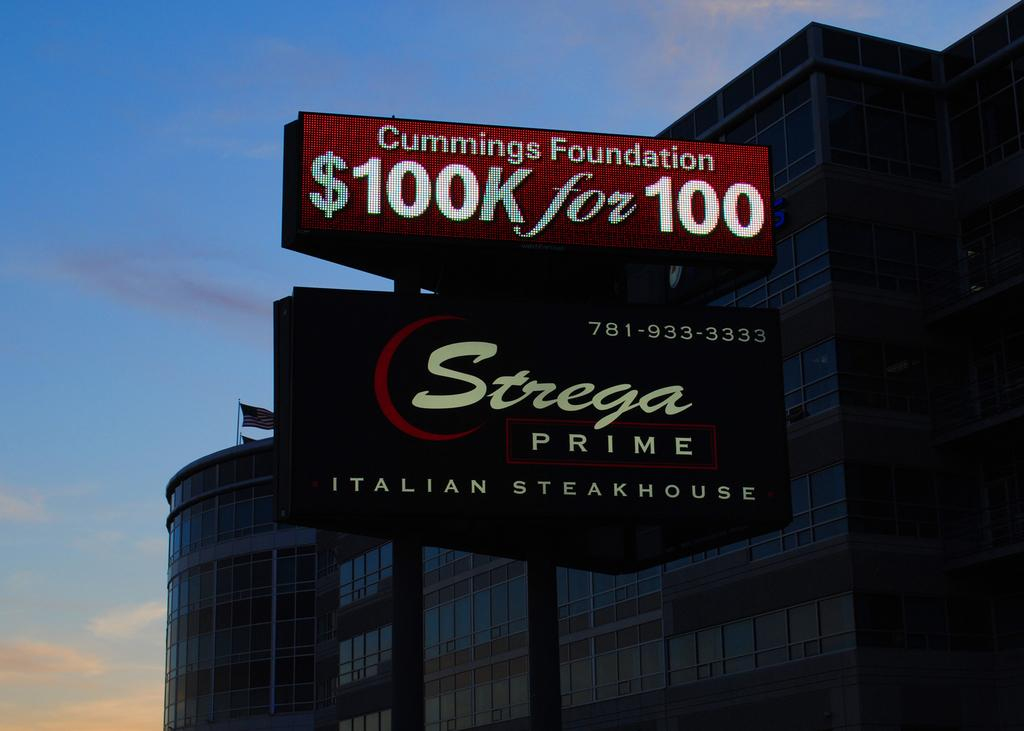<image>
Give a short and clear explanation of the subsequent image. a lit up sign on a building at twilight for Strega Prime 